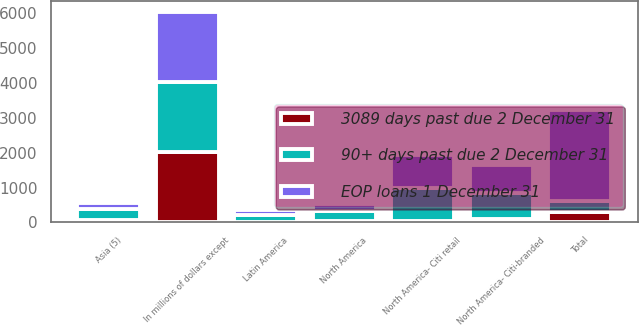Convert chart. <chart><loc_0><loc_0><loc_500><loc_500><stacked_bar_chart><ecel><fcel>In millions of dollars except<fcel>Total<fcel>North America<fcel>Latin America<fcel>Asia (5)<fcel>North America- Citi-branded<fcel>North America- Citi retail<nl><fcel>3089 days past due 2 December 31<fcel>2018<fcel>315.2<fcel>56.8<fcel>19.7<fcel>69.2<fcel>91.8<fcel>52.7<nl><fcel>EOP loans 1 December 31<fcel>2018<fcel>2619<fcel>180<fcel>127<fcel>178<fcel>812<fcel>952<nl><fcel>90+ days past due 2 December 31<fcel>2018<fcel>294.5<fcel>282<fcel>201<fcel>307<fcel>755<fcel>932<nl></chart> 